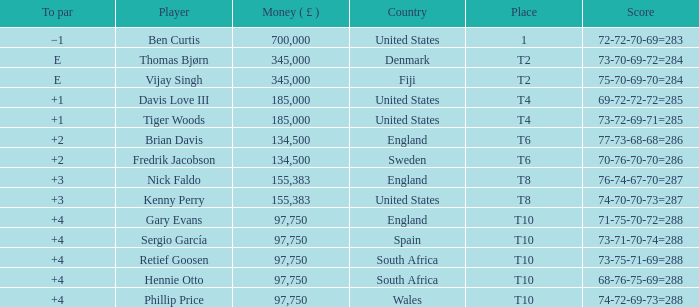What is the Place of Davis Love III with a To Par of +1? T4. 